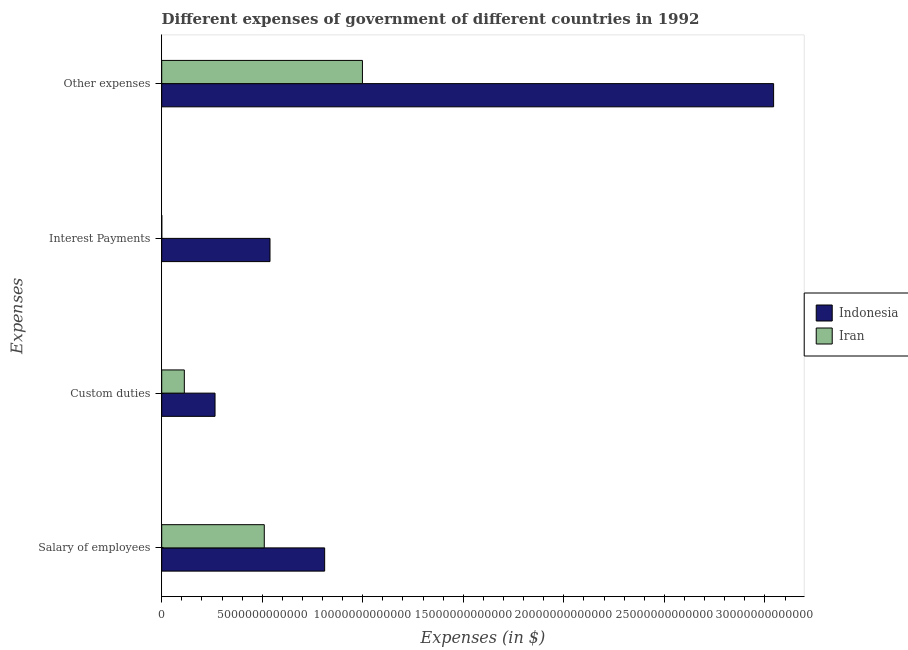How many different coloured bars are there?
Provide a short and direct response. 2. Are the number of bars per tick equal to the number of legend labels?
Ensure brevity in your answer.  Yes. Are the number of bars on each tick of the Y-axis equal?
Ensure brevity in your answer.  Yes. How many bars are there on the 2nd tick from the top?
Keep it short and to the point. 2. How many bars are there on the 2nd tick from the bottom?
Keep it short and to the point. 2. What is the label of the 4th group of bars from the top?
Keep it short and to the point. Salary of employees. What is the amount spent on salary of employees in Iran?
Keep it short and to the point. 5.10e+12. Across all countries, what is the maximum amount spent on other expenses?
Give a very brief answer. 3.04e+13. Across all countries, what is the minimum amount spent on custom duties?
Your answer should be compact. 1.12e+12. In which country was the amount spent on salary of employees maximum?
Provide a succinct answer. Indonesia. In which country was the amount spent on other expenses minimum?
Provide a short and direct response. Iran. What is the total amount spent on salary of employees in the graph?
Give a very brief answer. 1.32e+13. What is the difference between the amount spent on interest payments in Indonesia and that in Iran?
Provide a succinct answer. 5.38e+12. What is the difference between the amount spent on interest payments in Iran and the amount spent on other expenses in Indonesia?
Give a very brief answer. -3.04e+13. What is the average amount spent on interest payments per country?
Ensure brevity in your answer.  2.69e+12. What is the difference between the amount spent on custom duties and amount spent on other expenses in Indonesia?
Offer a terse response. -2.78e+13. In how many countries, is the amount spent on custom duties greater than 29000000000000 $?
Offer a very short reply. 0. What is the ratio of the amount spent on interest payments in Iran to that in Indonesia?
Your answer should be very brief. 0. Is the amount spent on interest payments in Indonesia less than that in Iran?
Your answer should be very brief. No. Is the difference between the amount spent on salary of employees in Iran and Indonesia greater than the difference between the amount spent on other expenses in Iran and Indonesia?
Ensure brevity in your answer.  Yes. What is the difference between the highest and the second highest amount spent on interest payments?
Offer a terse response. 5.38e+12. What is the difference between the highest and the lowest amount spent on salary of employees?
Offer a very short reply. 3.00e+12. In how many countries, is the amount spent on other expenses greater than the average amount spent on other expenses taken over all countries?
Keep it short and to the point. 1. Is it the case that in every country, the sum of the amount spent on custom duties and amount spent on interest payments is greater than the sum of amount spent on salary of employees and amount spent on other expenses?
Your answer should be compact. No. What does the 1st bar from the top in Salary of employees represents?
Ensure brevity in your answer.  Iran. What does the 1st bar from the bottom in Custom duties represents?
Make the answer very short. Indonesia. How many bars are there?
Offer a terse response. 8. What is the difference between two consecutive major ticks on the X-axis?
Make the answer very short. 5.00e+12. Are the values on the major ticks of X-axis written in scientific E-notation?
Your answer should be very brief. No. Does the graph contain grids?
Your response must be concise. No. Where does the legend appear in the graph?
Your response must be concise. Center right. What is the title of the graph?
Keep it short and to the point. Different expenses of government of different countries in 1992. Does "St. Kitts and Nevis" appear as one of the legend labels in the graph?
Your response must be concise. No. What is the label or title of the X-axis?
Ensure brevity in your answer.  Expenses (in $). What is the label or title of the Y-axis?
Provide a short and direct response. Expenses. What is the Expenses (in $) in Indonesia in Salary of employees?
Your answer should be very brief. 8.10e+12. What is the Expenses (in $) in Iran in Salary of employees?
Ensure brevity in your answer.  5.10e+12. What is the Expenses (in $) in Indonesia in Custom duties?
Offer a terse response. 2.65e+12. What is the Expenses (in $) of Iran in Custom duties?
Provide a short and direct response. 1.12e+12. What is the Expenses (in $) of Indonesia in Interest Payments?
Your answer should be very brief. 5.39e+12. What is the Expenses (in $) in Iran in Interest Payments?
Your answer should be very brief. 3.00e+09. What is the Expenses (in $) in Indonesia in Other expenses?
Offer a very short reply. 3.04e+13. What is the Expenses (in $) in Iran in Other expenses?
Offer a very short reply. 9.98e+12. Across all Expenses, what is the maximum Expenses (in $) of Indonesia?
Give a very brief answer. 3.04e+13. Across all Expenses, what is the maximum Expenses (in $) in Iran?
Keep it short and to the point. 9.98e+12. Across all Expenses, what is the minimum Expenses (in $) of Indonesia?
Give a very brief answer. 2.65e+12. Across all Expenses, what is the minimum Expenses (in $) in Iran?
Provide a short and direct response. 3.00e+09. What is the total Expenses (in $) in Indonesia in the graph?
Keep it short and to the point. 4.66e+13. What is the total Expenses (in $) in Iran in the graph?
Keep it short and to the point. 1.62e+13. What is the difference between the Expenses (in $) in Indonesia in Salary of employees and that in Custom duties?
Your response must be concise. 5.45e+12. What is the difference between the Expenses (in $) in Iran in Salary of employees and that in Custom duties?
Offer a very short reply. 3.98e+12. What is the difference between the Expenses (in $) in Indonesia in Salary of employees and that in Interest Payments?
Offer a very short reply. 2.72e+12. What is the difference between the Expenses (in $) in Iran in Salary of employees and that in Interest Payments?
Provide a short and direct response. 5.10e+12. What is the difference between the Expenses (in $) in Indonesia in Salary of employees and that in Other expenses?
Ensure brevity in your answer.  -2.23e+13. What is the difference between the Expenses (in $) in Iran in Salary of employees and that in Other expenses?
Your answer should be compact. -4.88e+12. What is the difference between the Expenses (in $) of Indonesia in Custom duties and that in Interest Payments?
Keep it short and to the point. -2.73e+12. What is the difference between the Expenses (in $) of Iran in Custom duties and that in Interest Payments?
Your response must be concise. 1.12e+12. What is the difference between the Expenses (in $) in Indonesia in Custom duties and that in Other expenses?
Keep it short and to the point. -2.78e+13. What is the difference between the Expenses (in $) in Iran in Custom duties and that in Other expenses?
Offer a very short reply. -8.86e+12. What is the difference between the Expenses (in $) in Indonesia in Interest Payments and that in Other expenses?
Provide a short and direct response. -2.50e+13. What is the difference between the Expenses (in $) in Iran in Interest Payments and that in Other expenses?
Your answer should be very brief. -9.98e+12. What is the difference between the Expenses (in $) in Indonesia in Salary of employees and the Expenses (in $) in Iran in Custom duties?
Your response must be concise. 6.98e+12. What is the difference between the Expenses (in $) in Indonesia in Salary of employees and the Expenses (in $) in Iran in Interest Payments?
Ensure brevity in your answer.  8.10e+12. What is the difference between the Expenses (in $) in Indonesia in Salary of employees and the Expenses (in $) in Iran in Other expenses?
Your response must be concise. -1.88e+12. What is the difference between the Expenses (in $) of Indonesia in Custom duties and the Expenses (in $) of Iran in Interest Payments?
Your response must be concise. 2.65e+12. What is the difference between the Expenses (in $) of Indonesia in Custom duties and the Expenses (in $) of Iran in Other expenses?
Your response must be concise. -7.33e+12. What is the difference between the Expenses (in $) in Indonesia in Interest Payments and the Expenses (in $) in Iran in Other expenses?
Keep it short and to the point. -4.60e+12. What is the average Expenses (in $) of Indonesia per Expenses?
Offer a terse response. 1.16e+13. What is the average Expenses (in $) in Iran per Expenses?
Give a very brief answer. 4.05e+12. What is the difference between the Expenses (in $) of Indonesia and Expenses (in $) of Iran in Salary of employees?
Your answer should be very brief. 3.00e+12. What is the difference between the Expenses (in $) of Indonesia and Expenses (in $) of Iran in Custom duties?
Your answer should be compact. 1.53e+12. What is the difference between the Expenses (in $) in Indonesia and Expenses (in $) in Iran in Interest Payments?
Give a very brief answer. 5.38e+12. What is the difference between the Expenses (in $) in Indonesia and Expenses (in $) in Iran in Other expenses?
Ensure brevity in your answer.  2.04e+13. What is the ratio of the Expenses (in $) in Indonesia in Salary of employees to that in Custom duties?
Provide a short and direct response. 3.06. What is the ratio of the Expenses (in $) in Iran in Salary of employees to that in Custom duties?
Ensure brevity in your answer.  4.54. What is the ratio of the Expenses (in $) in Indonesia in Salary of employees to that in Interest Payments?
Make the answer very short. 1.5. What is the ratio of the Expenses (in $) in Iran in Salary of employees to that in Interest Payments?
Keep it short and to the point. 1700.33. What is the ratio of the Expenses (in $) in Indonesia in Salary of employees to that in Other expenses?
Ensure brevity in your answer.  0.27. What is the ratio of the Expenses (in $) of Iran in Salary of employees to that in Other expenses?
Give a very brief answer. 0.51. What is the ratio of the Expenses (in $) in Indonesia in Custom duties to that in Interest Payments?
Make the answer very short. 0.49. What is the ratio of the Expenses (in $) in Iran in Custom duties to that in Interest Payments?
Make the answer very short. 374.83. What is the ratio of the Expenses (in $) in Indonesia in Custom duties to that in Other expenses?
Ensure brevity in your answer.  0.09. What is the ratio of the Expenses (in $) of Iran in Custom duties to that in Other expenses?
Provide a succinct answer. 0.11. What is the ratio of the Expenses (in $) of Indonesia in Interest Payments to that in Other expenses?
Offer a very short reply. 0.18. What is the ratio of the Expenses (in $) of Iran in Interest Payments to that in Other expenses?
Provide a succinct answer. 0. What is the difference between the highest and the second highest Expenses (in $) in Indonesia?
Ensure brevity in your answer.  2.23e+13. What is the difference between the highest and the second highest Expenses (in $) in Iran?
Offer a terse response. 4.88e+12. What is the difference between the highest and the lowest Expenses (in $) in Indonesia?
Provide a short and direct response. 2.78e+13. What is the difference between the highest and the lowest Expenses (in $) in Iran?
Your answer should be very brief. 9.98e+12. 